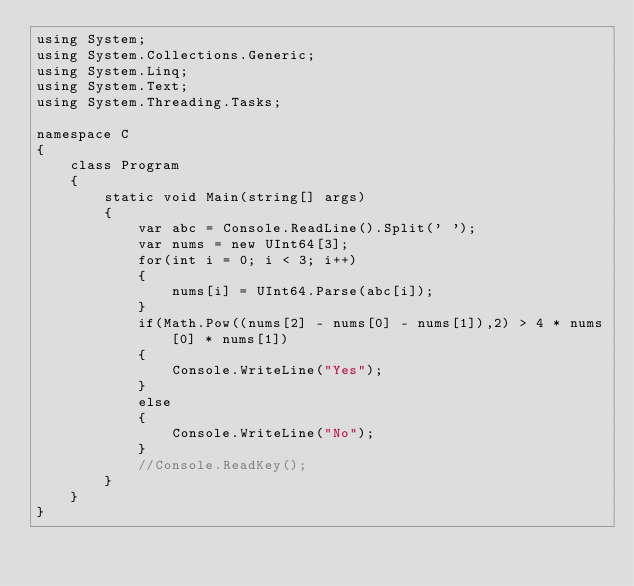<code> <loc_0><loc_0><loc_500><loc_500><_C#_>using System;
using System.Collections.Generic;
using System.Linq;
using System.Text;
using System.Threading.Tasks;

namespace C
{
    class Program
    {
        static void Main(string[] args)
        {
            var abc = Console.ReadLine().Split(' ');
            var nums = new UInt64[3];
            for(int i = 0; i < 3; i++)
            {
                nums[i] = UInt64.Parse(abc[i]);
            }
            if(Math.Pow((nums[2] - nums[0] - nums[1]),2) > 4 * nums[0] * nums[1])
            {
                Console.WriteLine("Yes");
            }
            else
            {
                Console.WriteLine("No");
            }
            //Console.ReadKey();
        }
    }
}
</code> 